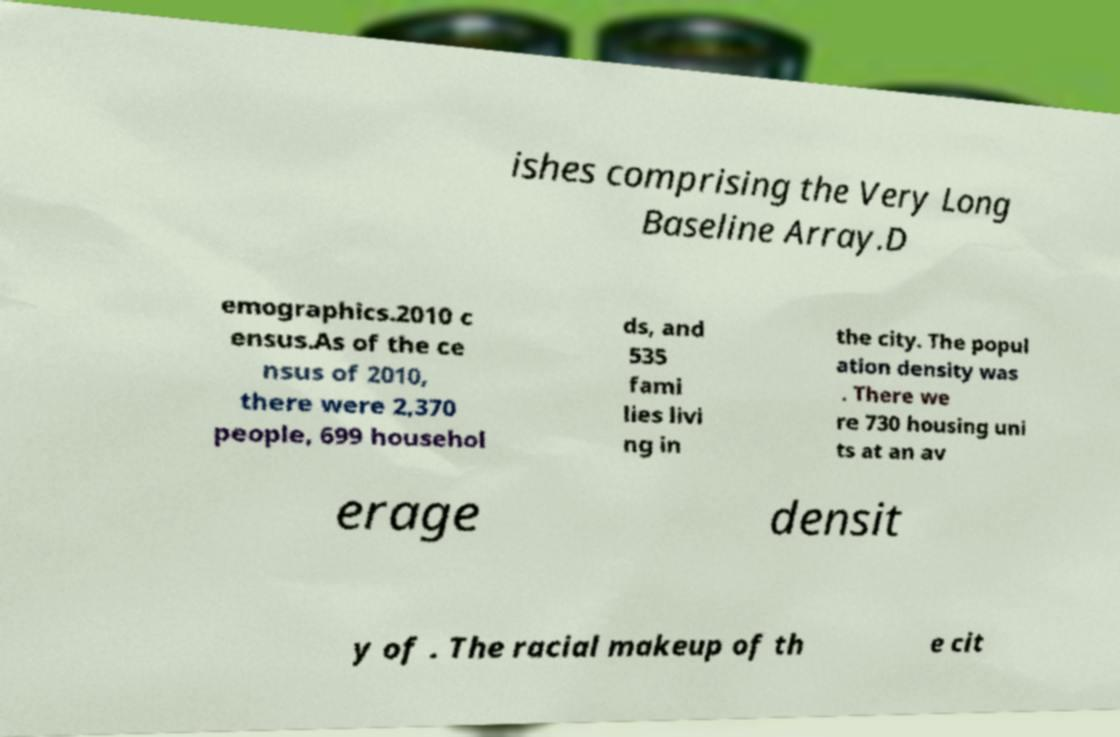For documentation purposes, I need the text within this image transcribed. Could you provide that? ishes comprising the Very Long Baseline Array.D emographics.2010 c ensus.As of the ce nsus of 2010, there were 2,370 people, 699 househol ds, and 535 fami lies livi ng in the city. The popul ation density was . There we re 730 housing uni ts at an av erage densit y of . The racial makeup of th e cit 